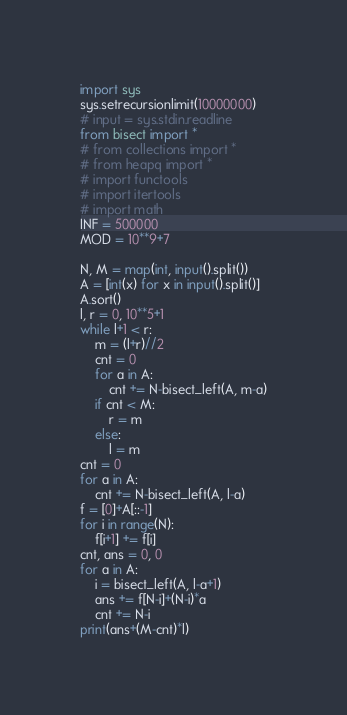<code> <loc_0><loc_0><loc_500><loc_500><_Python_>import sys
sys.setrecursionlimit(10000000)
# input = sys.stdin.readline
from bisect import *
# from collections import *
# from heapq import *
# import functools
# import itertools
# import math
INF = 500000
MOD = 10**9+7

N, M = map(int, input().split())
A = [int(x) for x in input().split()]
A.sort()
l, r = 0, 10**5+1
while l+1 < r:
    m = (l+r)//2
    cnt = 0
    for a in A:
        cnt += N-bisect_left(A, m-a)
    if cnt < M:
        r = m
    else:
        l = m
cnt = 0
for a in A:
    cnt += N-bisect_left(A, l-a)
f = [0]+A[::-1]
for i in range(N):
    f[i+1] += f[i]
cnt, ans = 0, 0
for a in A:
    i = bisect_left(A, l-a+1)
    ans += f[N-i]+(N-i)*a
    cnt += N-i
print(ans+(M-cnt)*l)
</code> 